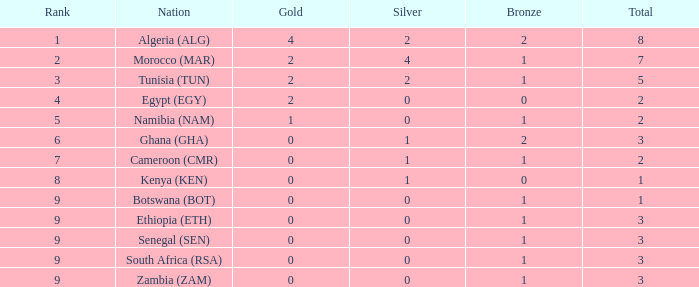What is the total number of Silver with a Total that is smaller than 1? 0.0. 